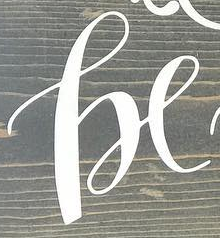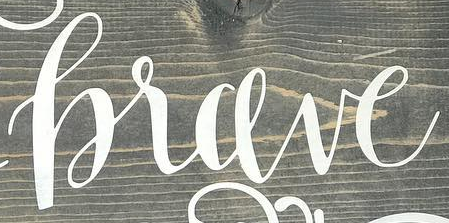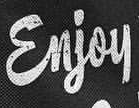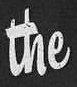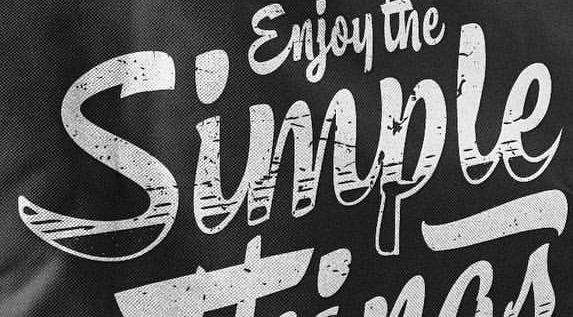Read the text from these images in sequence, separated by a semicolon. he; hrave; Enjoy; the; Simple 